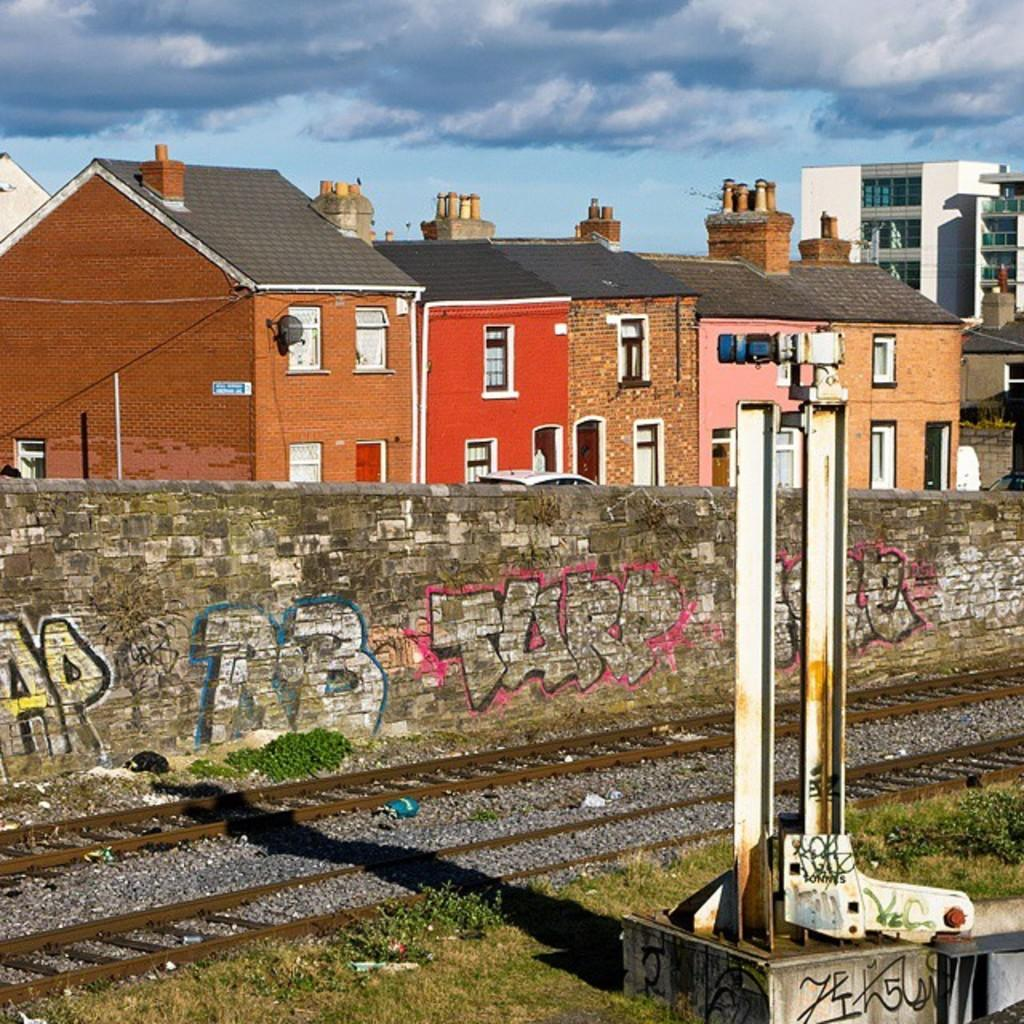What types of structures are present in the image? There are buildings and houses in the image. Can you describe any specific features of these structures? The image features a wall with writing. How many hands are visible on the buildings in the image? There are no hands visible on the buildings in the image. What type of bird can be seen perched on the wall with writing? There is no crow or any other bird present in the image. 